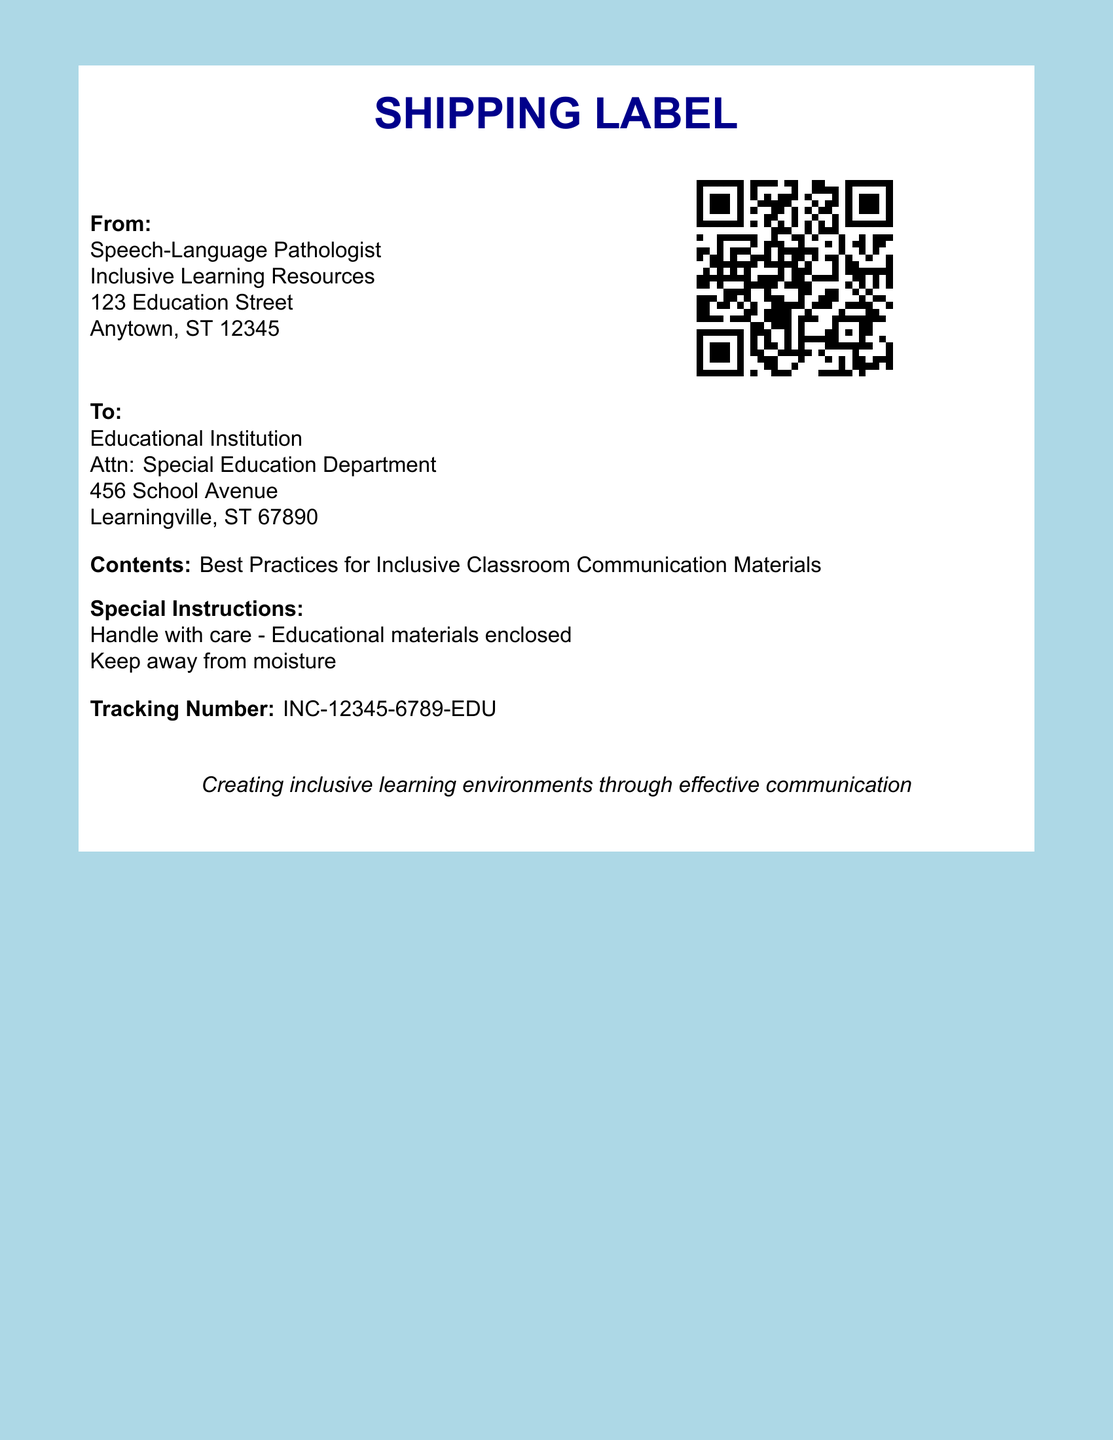What is the sender's title? The title of the sender is mentioned in the document as "Speech-Language Pathologist."
Answer: Speech-Language Pathologist What city is the recipient located in? The recipient's address indicates the city is "Learningville."
Answer: Learningville What is the tracking number? The document specifies the tracking number as "INC-12345-6789-EDU."
Answer: INC-12345-6789-EDU What type of materials are enclosed? The document states that the contents include "Best Practices for Inclusive Classroom Communication Materials."
Answer: Best Practices for Inclusive Classroom Communication Materials What special instruction is given regarding the materials? The document mentions to "Handle with care - Educational materials enclosed."
Answer: Handle with care - Educational materials enclosed What is the color of the page background? The background color is described as "lightblue" in the document.
Answer: lightblue What is indicated by the QR code? The QR code in the document directs to "https://example.com/inclusive-resources."
Answer: https://example.com/inclusive-resources What is the main message indicated at the bottom of the document? The bottom of the document includes a message stating "Creating inclusive learning environments through effective communication."
Answer: Creating inclusive learning environments through effective communication What is the street address of the sender? The sender's street address is listed as "123 Education Street."
Answer: 123 Education Street 